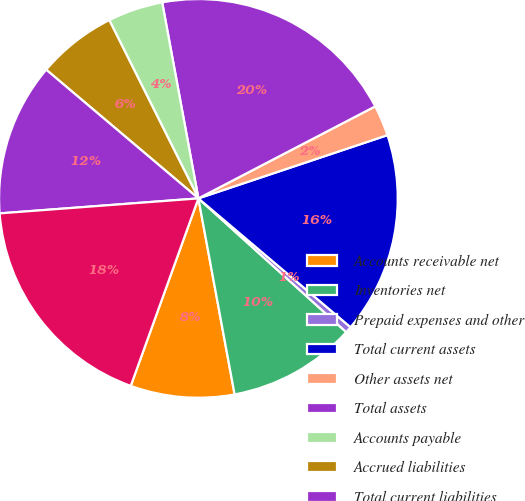Convert chart. <chart><loc_0><loc_0><loc_500><loc_500><pie_chart><fcel>Accounts receivable net<fcel>Inventories net<fcel>Prepaid expenses and other<fcel>Total current assets<fcel>Other assets net<fcel>Total assets<fcel>Accounts payable<fcel>Accrued liabilities<fcel>Total current liabilities<fcel>Retained earnings<nl><fcel>8.42%<fcel>10.39%<fcel>0.52%<fcel>16.32%<fcel>2.5%<fcel>20.27%<fcel>4.47%<fcel>6.45%<fcel>12.37%<fcel>18.29%<nl></chart> 